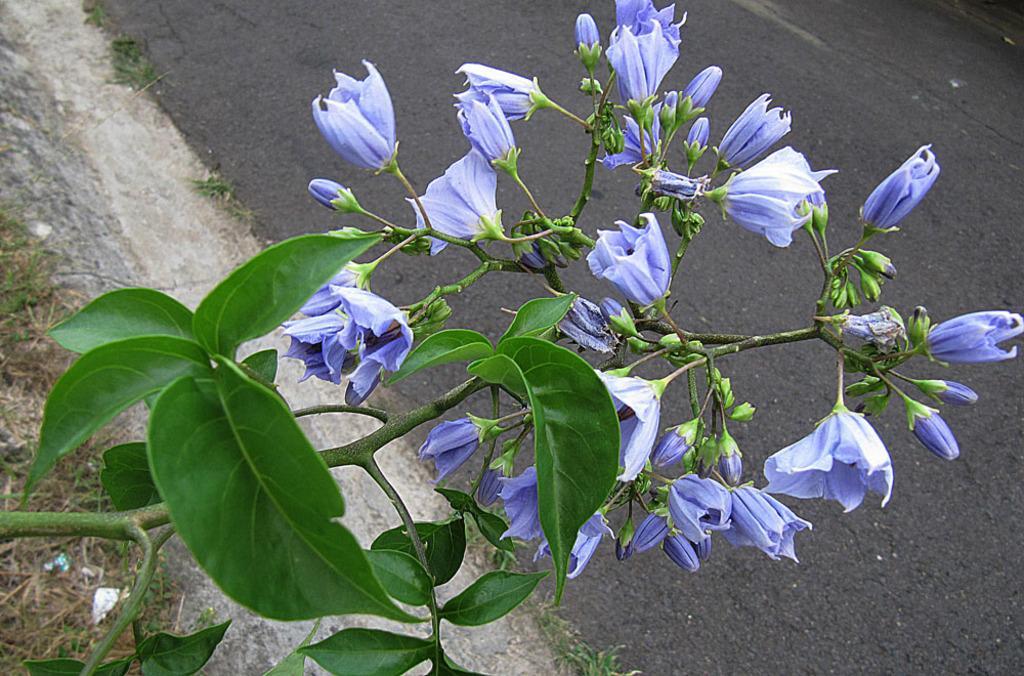Could you give a brief overview of what you see in this image? In this image we can see a group of flowers and buds. Behind the flowers we can see the road. 